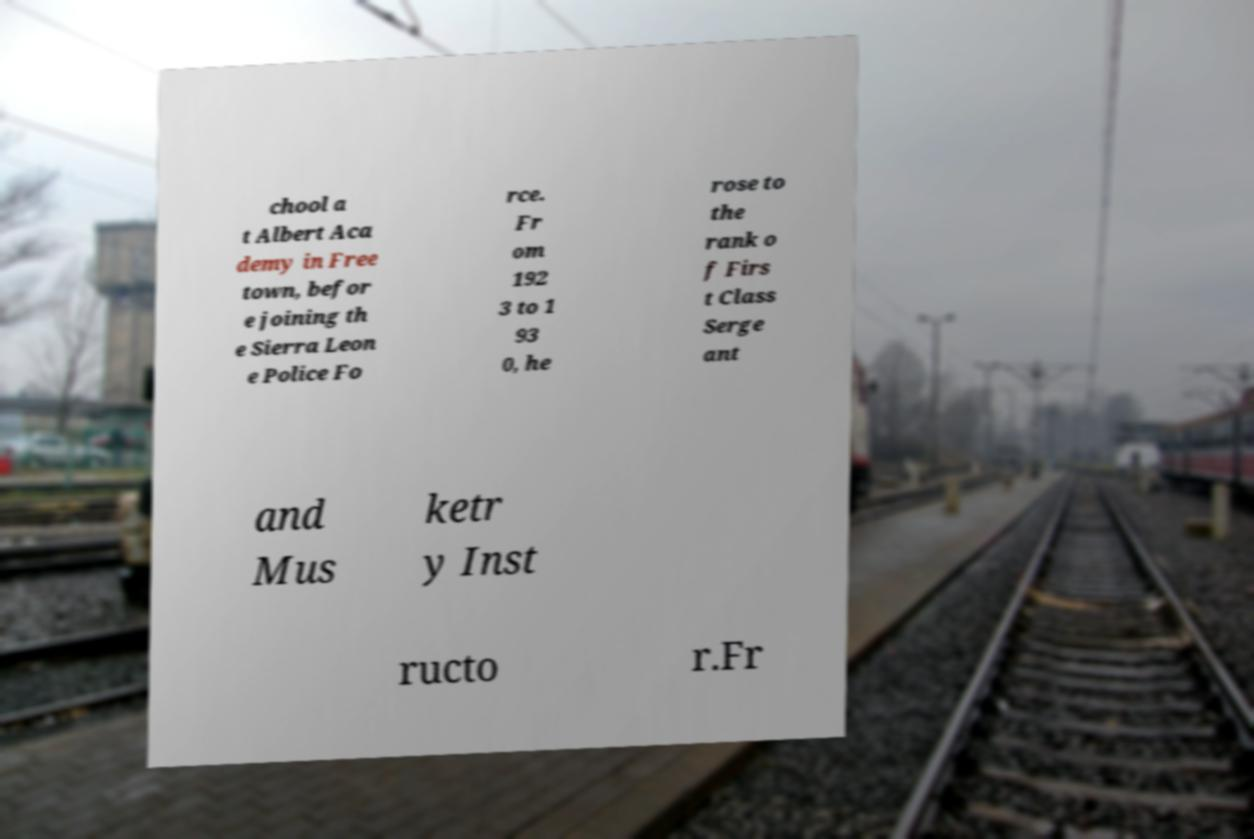There's text embedded in this image that I need extracted. Can you transcribe it verbatim? chool a t Albert Aca demy in Free town, befor e joining th e Sierra Leon e Police Fo rce. Fr om 192 3 to 1 93 0, he rose to the rank o f Firs t Class Serge ant and Mus ketr y Inst ructo r.Fr 